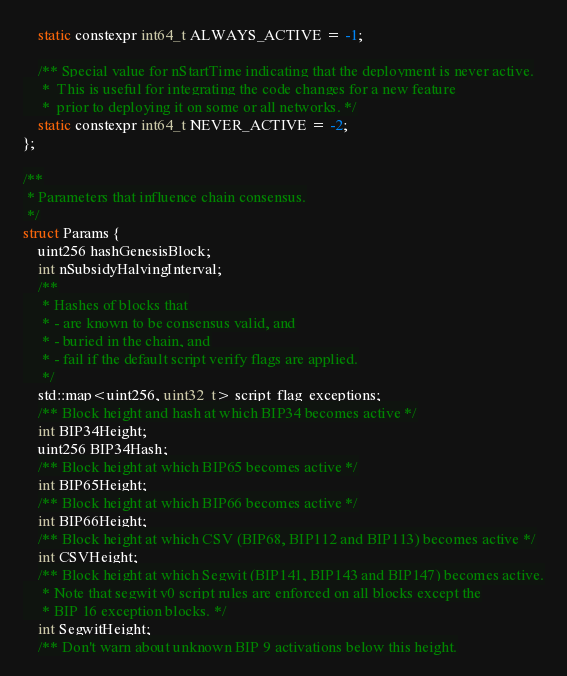Convert code to text. <code><loc_0><loc_0><loc_500><loc_500><_C_>    static constexpr int64_t ALWAYS_ACTIVE = -1;

    /** Special value for nStartTime indicating that the deployment is never active.
     *  This is useful for integrating the code changes for a new feature
     *  prior to deploying it on some or all networks. */
    static constexpr int64_t NEVER_ACTIVE = -2;
};

/**
 * Parameters that influence chain consensus.
 */
struct Params {
    uint256 hashGenesisBlock;
    int nSubsidyHalvingInterval;
    /**
     * Hashes of blocks that
     * - are known to be consensus valid, and
     * - buried in the chain, and
     * - fail if the default script verify flags are applied.
     */
    std::map<uint256, uint32_t> script_flag_exceptions;
    /** Block height and hash at which BIP34 becomes active */
    int BIP34Height;
    uint256 BIP34Hash;
    /** Block height at which BIP65 becomes active */
    int BIP65Height;
    /** Block height at which BIP66 becomes active */
    int BIP66Height;
    /** Block height at which CSV (BIP68, BIP112 and BIP113) becomes active */
    int CSVHeight;
    /** Block height at which Segwit (BIP141, BIP143 and BIP147) becomes active.
     * Note that segwit v0 script rules are enforced on all blocks except the
     * BIP 16 exception blocks. */
    int SegwitHeight;
    /** Don't warn about unknown BIP 9 activations below this height.</code> 